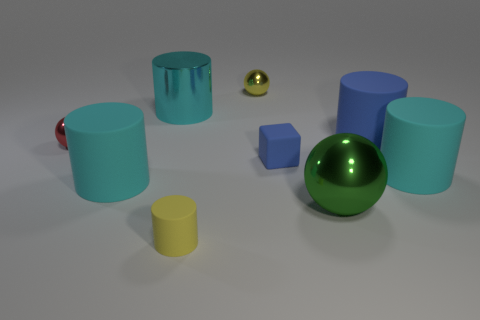What number of tiny metallic spheres are on the right side of the big blue rubber cylinder?
Your answer should be compact. 0. Do the cylinder that is in front of the green metal object and the tiny block have the same material?
Offer a very short reply. Yes. What number of tiny purple things have the same shape as the small red metallic thing?
Make the answer very short. 0. What number of big things are yellow matte cylinders or green balls?
Give a very brief answer. 1. Does the shiny thing that is in front of the red thing have the same color as the matte cube?
Your answer should be compact. No. Do the large metallic thing that is in front of the small blue cube and the tiny metal object that is right of the small red object have the same color?
Your answer should be very brief. No. Is there another large ball made of the same material as the large green ball?
Provide a short and direct response. No. What number of green objects are small metal objects or metal objects?
Provide a short and direct response. 1. Is the number of shiny things left of the block greater than the number of cyan rubber things?
Give a very brief answer. Yes. Do the cyan metallic cylinder and the yellow rubber cylinder have the same size?
Your response must be concise. No. 